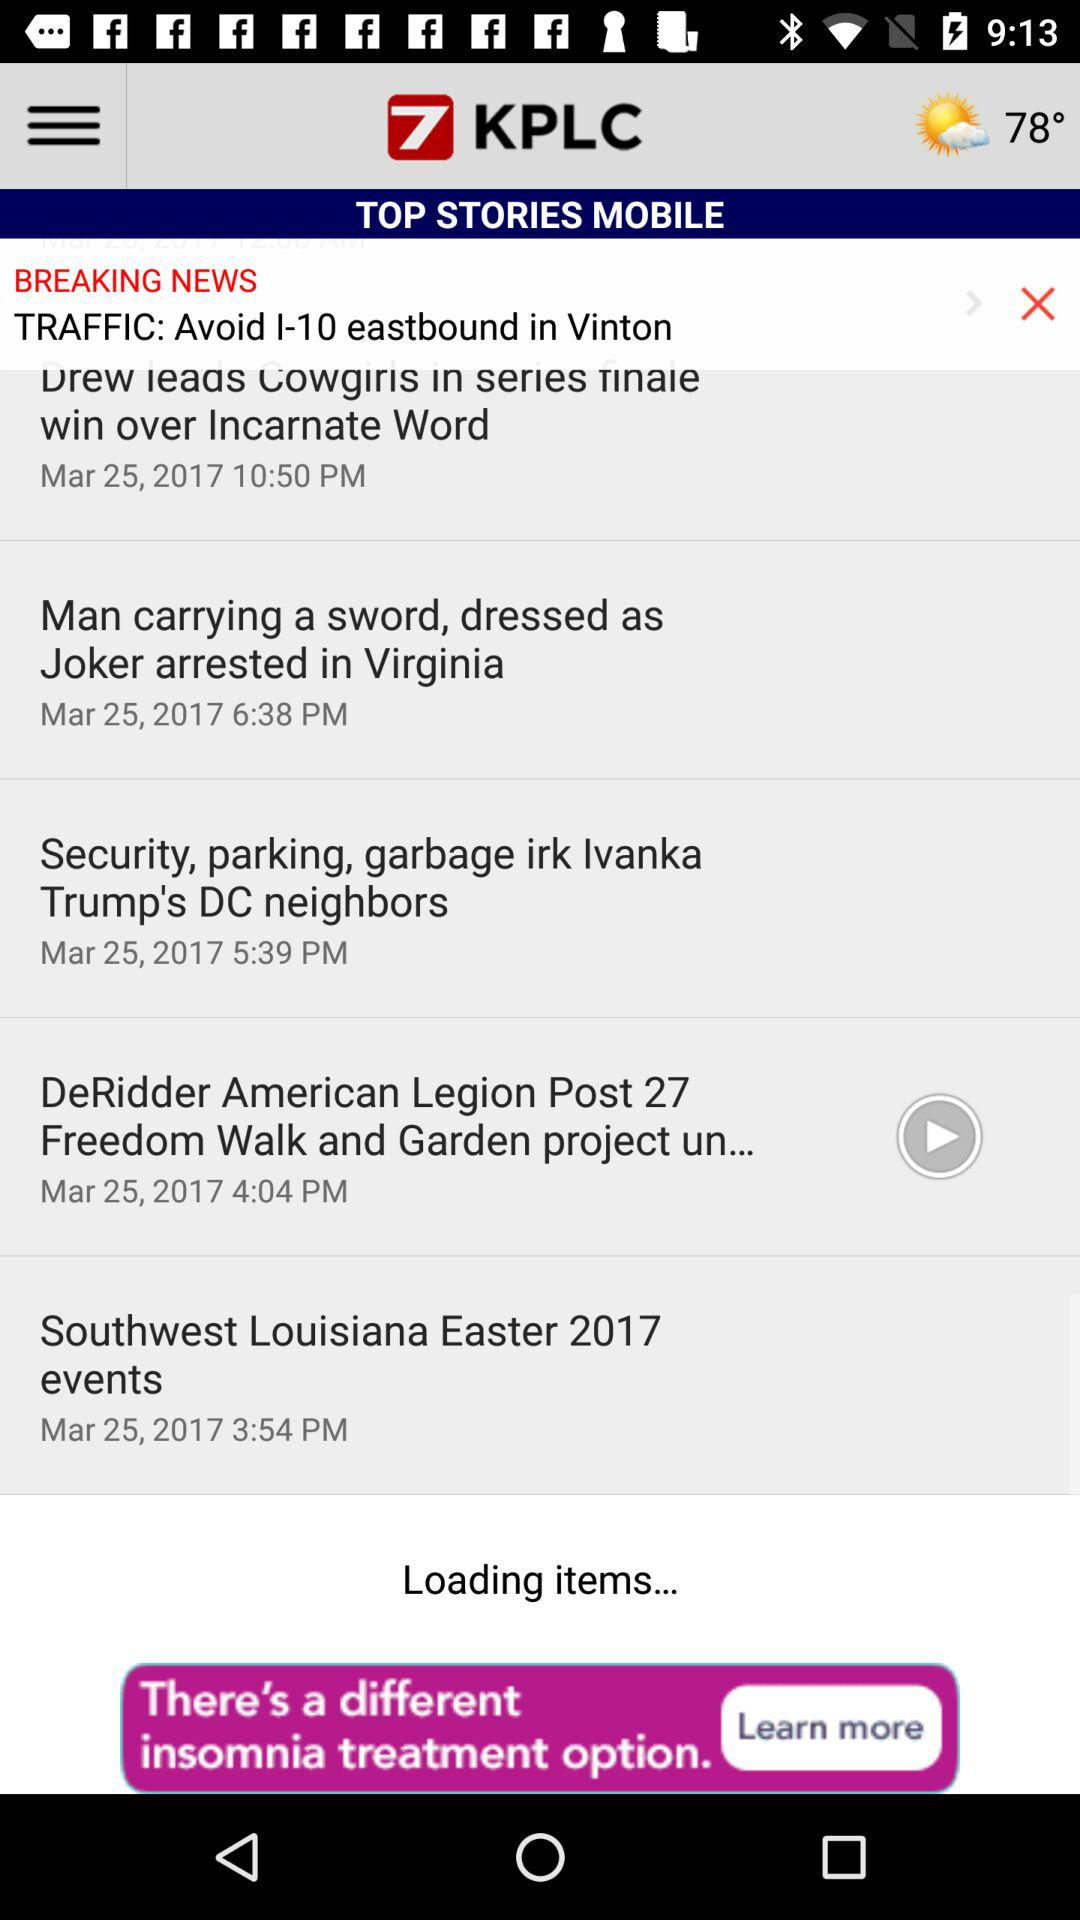What's the posted time of the "Southwest Louisiana Easter 2017 events"? The posted time of the "Southwest Louisiana Easter 2017 events" is 3:54 PM. 